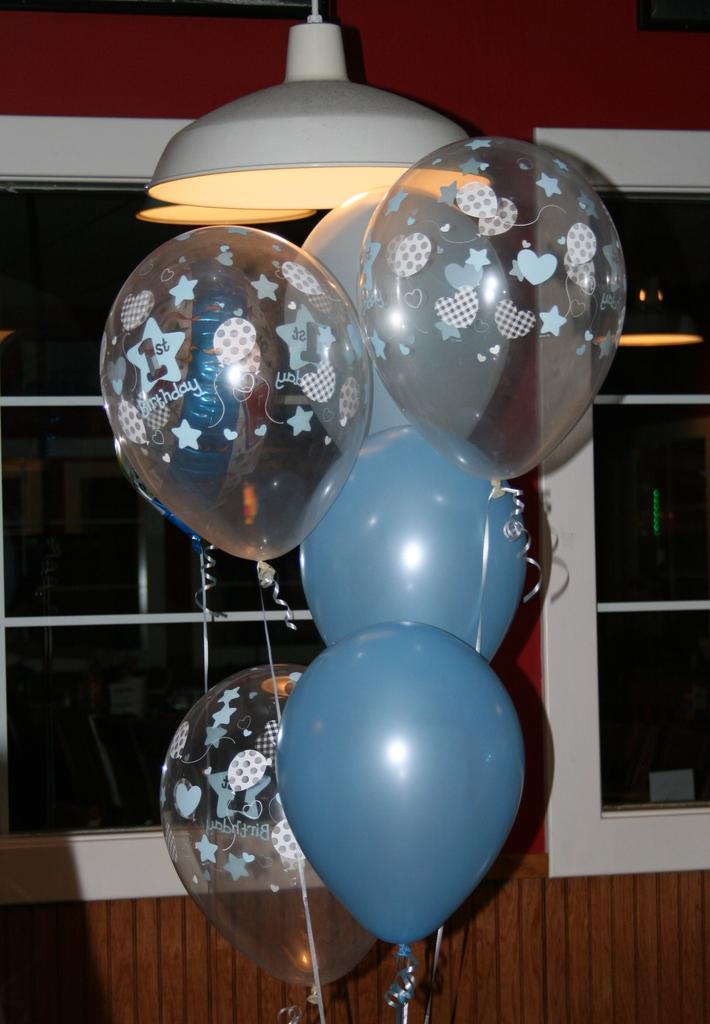What objects are located in the center of the image? There are balloons and lamps in the center of the image. Can you describe the background of the image? There are windows and a wall in the background of the image. How many brothers are visible in the image? There are no brothers present in the image. What type of pump is used to inflate the balloons in the image? There is no pump visible in the image, and it is not clear if the balloons are inflated or not. 